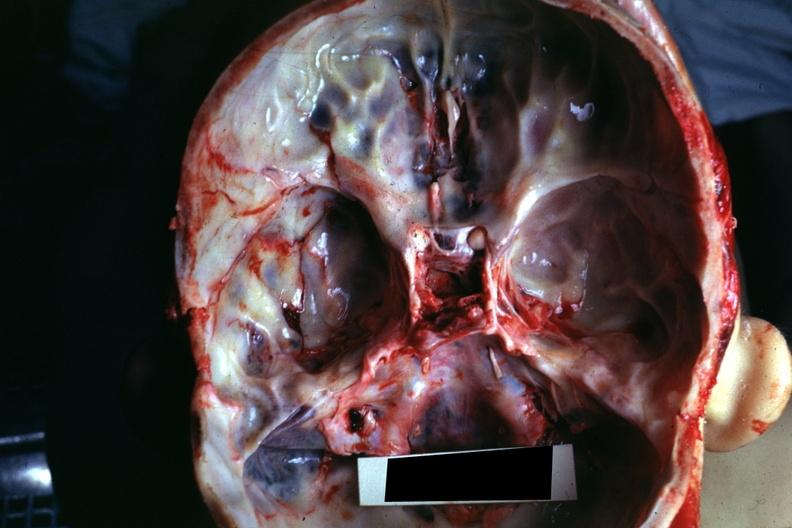what is present?
Answer the question using a single word or phrase. Bone, calvarium 